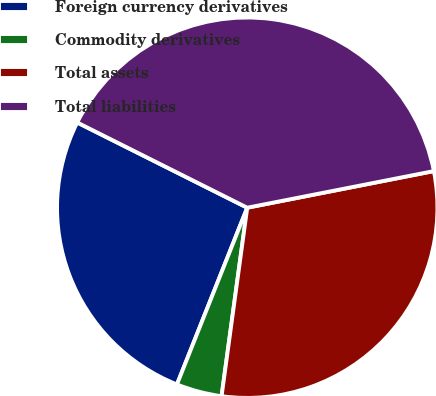<chart> <loc_0><loc_0><loc_500><loc_500><pie_chart><fcel>Foreign currency derivatives<fcel>Commodity derivatives<fcel>Total assets<fcel>Total liabilities<nl><fcel>26.37%<fcel>3.87%<fcel>30.24%<fcel>39.52%<nl></chart> 